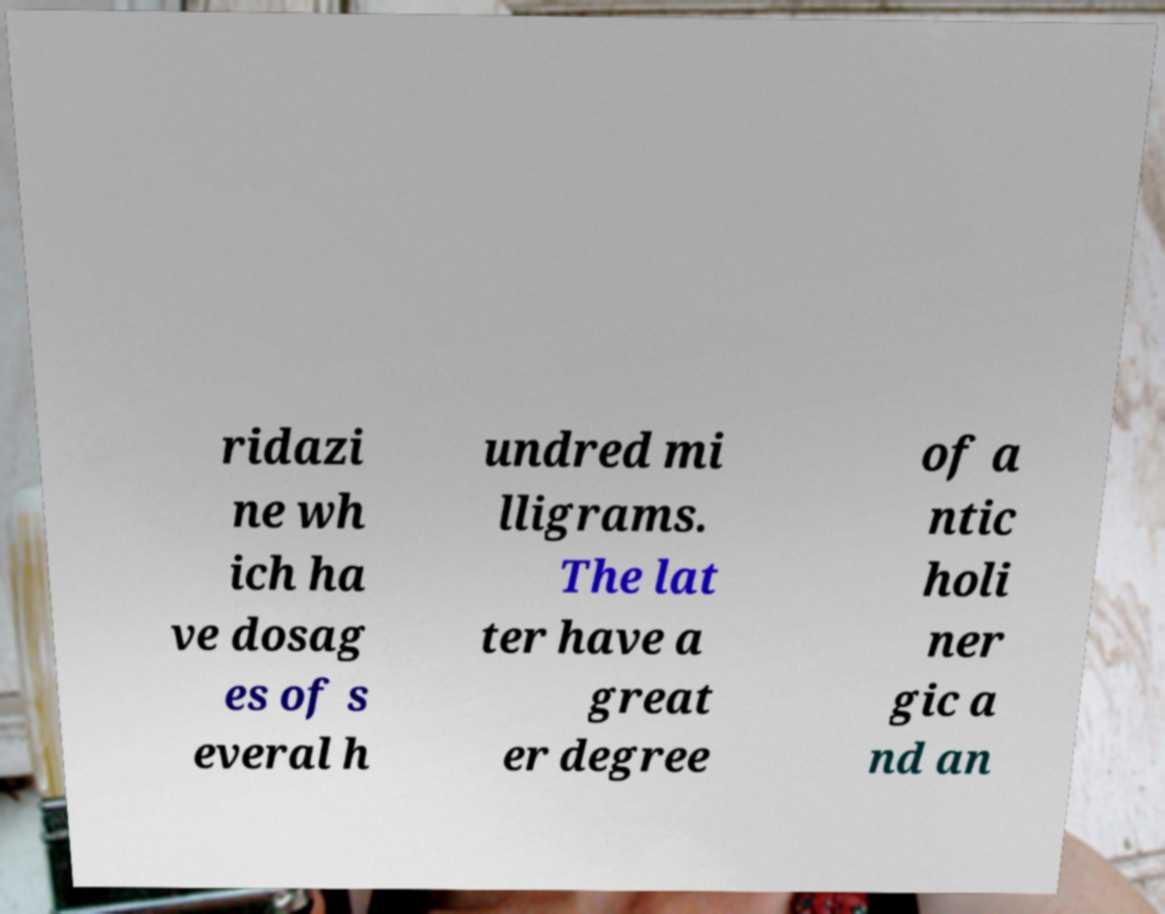For documentation purposes, I need the text within this image transcribed. Could you provide that? ridazi ne wh ich ha ve dosag es of s everal h undred mi lligrams. The lat ter have a great er degree of a ntic holi ner gic a nd an 